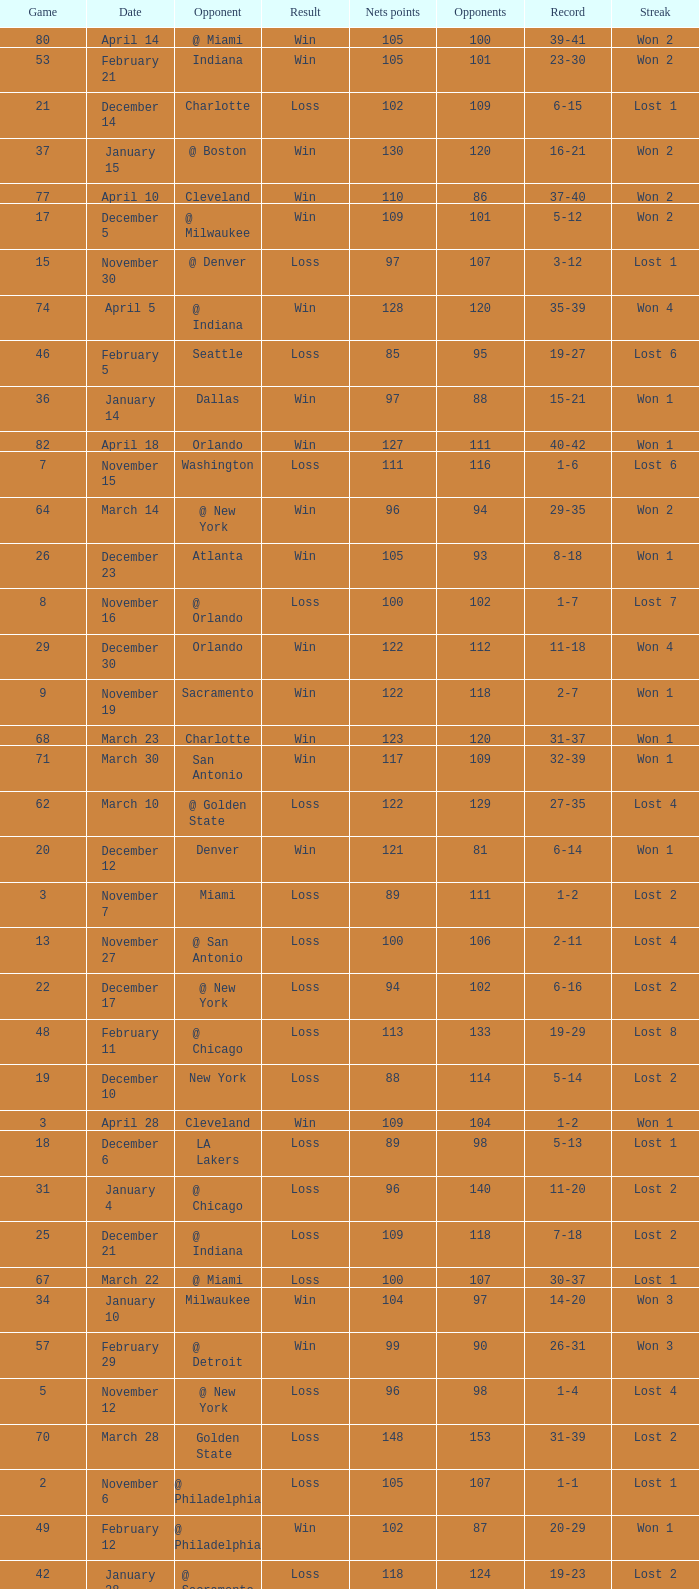How many games had fewer than 118 opponents and more than 109 net points with an opponent of Washington? 1.0. Parse the full table. {'header': ['Game', 'Date', 'Opponent', 'Result', 'Nets points', 'Opponents', 'Record', 'Streak'], 'rows': [['80', 'April 14', '@ Miami', 'Win', '105', '100', '39-41', 'Won 2'], ['53', 'February 21', 'Indiana', 'Win', '105', '101', '23-30', 'Won 2'], ['21', 'December 14', 'Charlotte', 'Loss', '102', '109', '6-15', 'Lost 1'], ['37', 'January 15', '@ Boston', 'Win', '130', '120', '16-21', 'Won 2'], ['77', 'April 10', 'Cleveland', 'Win', '110', '86', '37-40', 'Won 2'], ['17', 'December 5', '@ Milwaukee', 'Win', '109', '101', '5-12', 'Won 2'], ['15', 'November 30', '@ Denver', 'Loss', '97', '107', '3-12', 'Lost 1'], ['74', 'April 5', '@ Indiana', 'Win', '128', '120', '35-39', 'Won 4'], ['46', 'February 5', 'Seattle', 'Loss', '85', '95', '19-27', 'Lost 6'], ['36', 'January 14', 'Dallas', 'Win', '97', '88', '15-21', 'Won 1'], ['82', 'April 18', 'Orlando', 'Win', '127', '111', '40-42', 'Won 1'], ['7', 'November 15', 'Washington', 'Loss', '111', '116', '1-6', 'Lost 6'], ['64', 'March 14', '@ New York', 'Win', '96', '94', '29-35', 'Won 2'], ['26', 'December 23', 'Atlanta', 'Win', '105', '93', '8-18', 'Won 1'], ['8', 'November 16', '@ Orlando', 'Loss', '100', '102', '1-7', 'Lost 7'], ['29', 'December 30', 'Orlando', 'Win', '122', '112', '11-18', 'Won 4'], ['9', 'November 19', 'Sacramento', 'Win', '122', '118', '2-7', 'Won 1'], ['68', 'March 23', 'Charlotte', 'Win', '123', '120', '31-37', 'Won 1'], ['71', 'March 30', 'San Antonio', 'Win', '117', '109', '32-39', 'Won 1'], ['62', 'March 10', '@ Golden State', 'Loss', '122', '129', '27-35', 'Lost 4'], ['20', 'December 12', 'Denver', 'Win', '121', '81', '6-14', 'Won 1'], ['3', 'November 7', 'Miami', 'Loss', '89', '111', '1-2', 'Lost 2'], ['13', 'November 27', '@ San Antonio', 'Loss', '100', '106', '2-11', 'Lost 4'], ['22', 'December 17', '@ New York', 'Loss', '94', '102', '6-16', 'Lost 2'], ['48', 'February 11', '@ Chicago', 'Loss', '113', '133', '19-29', 'Lost 8'], ['19', 'December 10', 'New York', 'Loss', '88', '114', '5-14', 'Lost 2'], ['3', 'April 28', 'Cleveland', 'Win', '109', '104', '1-2', 'Won 1'], ['18', 'December 6', 'LA Lakers', 'Loss', '89', '98', '5-13', 'Lost 1'], ['31', 'January 4', '@ Chicago', 'Loss', '96', '140', '11-20', 'Lost 2'], ['25', 'December 21', '@ Indiana', 'Loss', '109', '118', '7-18', 'Lost 2'], ['67', 'March 22', '@ Miami', 'Loss', '100', '107', '30-37', 'Lost 1'], ['34', 'January 10', 'Milwaukee', 'Win', '104', '97', '14-20', 'Won 3'], ['57', 'February 29', '@ Detroit', 'Win', '99', '90', '26-31', 'Won 3'], ['5', 'November 12', '@ New York', 'Loss', '96', '98', '1-4', 'Lost 4'], ['70', 'March 28', 'Golden State', 'Loss', '148', '153', '31-39', 'Lost 2'], ['2', 'November 6', '@ Philadelphia', 'Loss', '105', '107', '1-1', 'Lost 1'], ['49', 'February 12', '@ Philadelphia', 'Win', '102', '87', '20-29', 'Won 1'], ['42', 'January 28', '@ Sacramento', 'Loss', '118', '124', '19-23', 'Lost 2'], ['45', 'February 1', '@ LA Clippers', 'Loss', '88', '99', '19-26', 'Lost 5'], ['44', 'January 31', '@ Portland', 'Loss', '108', '113', '19-25', 'Lost 4'], ['14', 'November 29', '@ Dallas', 'Win', '97', '91', '3-11', 'Won 1'], ['54', 'February 22', '@ Atlanta', 'Loss', '107', '119', '23-31', 'Lost 1'], ['65', 'March 17', 'Chicago', 'Loss', '79', '90', '29-36', 'Lost 1'], ['40', 'January 24', 'Miami', 'Win', '123', '117', '19-21', 'Won 5'], ['55', 'February 25', 'Boston', 'Win', '109', '95', '24-31', 'Won 1'], ['72', 'April 1', '@ Milwaukee', 'Win', '121', '117', '33-39', 'Won 2'], ['41', 'January 25', '@ Philadelphia', 'Loss', '94', '115', '19-22', 'Lost 1'], ['28', 'December 27', '@ Charlotte', 'Win', '136', '120', '10-18', 'Won 3'], ['43', 'January 29', '@ Phoenix', 'Loss', '95', '128', '19-24', 'Lost 3'], ['79', 'April 13', '@ Orlando', 'Win', '110', '104', '38-41', 'Won 1'], ['56', 'February 27', 'Portland', 'Win', '98', '96', '25-31', 'Won 2'], ['16', 'December 3', 'Philadelphia', 'Win', '88', '86', '4-12', 'Won 1'], ['66', 'March 20', 'Washington', 'Win', '99', '96', '30-36', 'Won 1'], ['61', 'March 7', '@ Seattle', 'Loss', '98', '109', '27-34', 'Lost 3'], ['59', 'March 4', '@ LA Lakers', 'Loss', '92', '101', '27-32', 'Lost 1'], ['38', 'January 18', '@ Minnesota', 'Win', '112', '100', '17-21', 'Won 3'], ['73', 'April 3', 'Milwaukee', 'Win', '122', '103', '34-39', 'Won 3'], ['51', 'February 15', '@ Cleveland', 'Loss', '92', '128', '21-30', 'Lost 1'], ['30', 'January 3', 'Washington', 'Loss', '108', '112', '11-19', 'Lost 1'], ['23', 'December 18', 'Cleveland', 'Win', '102', '93', '7-16', 'Won 1'], ['10', 'November 21', '@ Cleveland', 'Loss', '112', '116', '2-8', 'Lost 1'], ['6', 'November 13', 'Utah', 'Loss', '92', '98', '1-5', 'Lost 5'], ['52', 'February 19', 'Detroit', 'Win', '106', '102', '22-30', 'Won 1'], ['12', 'November 26', '@ Houston', 'Loss', '109', '118', '2-10', 'Lost 3'], ['76', 'April 8', '@ Washington', 'Win', '109', '103', '36-40', 'Won 1'], ['47', 'February 6', '@ Washington', 'Loss', '108', '124', '19-28', 'Lost 7'], ['2', 'April 25', '@ Cleveland', 'Loss', '96', '118', '0-2', 'Lost 2'], ['60', 'March 6', '@ Utah', 'Loss', '96', '117', '27-33', 'Lost 2'], ['58', 'March 1', 'New York', 'Win', '90', '75', '27-31', 'Won 4'], ['81', 'April 16', 'Indiana', 'Loss', '113', '119', '39-42', 'Lost 1'], ['35', 'January 11', '@ Detroit', 'Loss', '88', '90', '14-21', 'Lost 1'], ['4', 'April 30', 'Cleveland', 'Loss', '89', '98', '1-3', 'Lost 1'], ['33', 'January 8', 'Minnesota', 'Win', '103', '97', '13-20', 'Won 2'], ['78', 'April 11', '@ Atlanta', 'Loss', '98', '118', '37-41', 'Lost 1'], ['75', 'April 7', 'Atlanta', 'Loss', '97', '104', '35-40', 'Lost 1'], ['24', 'December 20', 'Chicago', 'Loss', '98', '115', '7-17', 'Lost 1'], ['1', 'November 2', '@ Charlotte', 'Win', '116', '118', '1-0', 'Won 1'], ['69', 'March 25', 'Boston', 'Loss', '110', '118', '31-38', 'Lost 1'], ['11', 'November 23', 'Boston', 'Loss', '107', '125', '2-9', 'Lost 2'], ['1', 'April 23', '@ Cleveland', 'Loss', '113', '120', '0-1', 'Lost 1'], ['32', 'January 6', 'LA Clippers', 'Win', '105', '90', '12-20', 'Won 1'], ['4', 'November 9', 'Detroit', 'Loss', '100', '110', '1-3', 'Lost 3'], ['39', 'January 22', 'Phoenix', 'Win', '106', '104', '18-21', 'Won 4'], ['27', 'December 26', 'Houston', 'Win', '99', '93', '9-18', 'Won 2'], ['63', 'March 13', '@ Boston', 'Win', '110', '108', '28-35', 'Won 1'], ['50', 'February 14', 'Philadelphia', 'Win', '107', '99', '21-29', 'Won 2']]} 